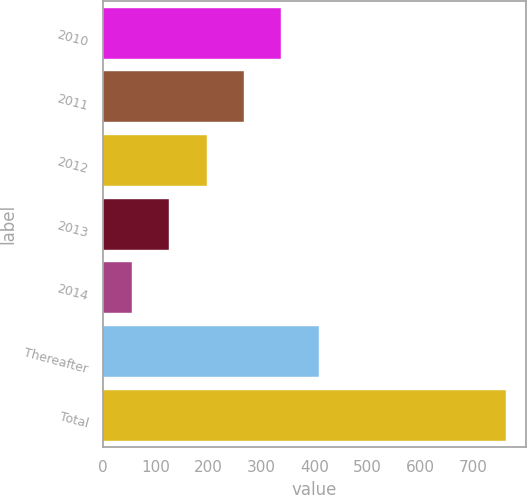Convert chart. <chart><loc_0><loc_0><loc_500><loc_500><bar_chart><fcel>2010<fcel>2011<fcel>2012<fcel>2013<fcel>2014<fcel>Thereafter<fcel>Total<nl><fcel>337.34<fcel>266.68<fcel>196.02<fcel>125.36<fcel>54.7<fcel>408<fcel>761.3<nl></chart> 